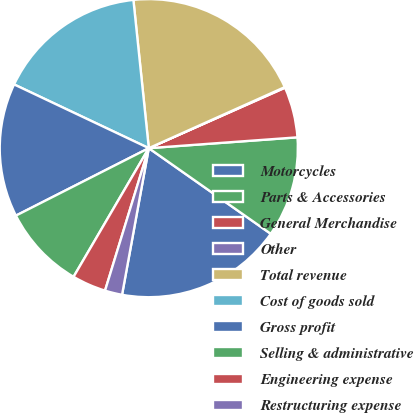Convert chart to OTSL. <chart><loc_0><loc_0><loc_500><loc_500><pie_chart><fcel>Motorcycles<fcel>Parts & Accessories<fcel>General Merchandise<fcel>Other<fcel>Total revenue<fcel>Cost of goods sold<fcel>Gross profit<fcel>Selling & administrative<fcel>Engineering expense<fcel>Restructuring expense<nl><fcel>18.13%<fcel>10.9%<fcel>5.49%<fcel>0.07%<fcel>19.93%<fcel>16.32%<fcel>14.51%<fcel>9.1%<fcel>3.68%<fcel>1.87%<nl></chart> 